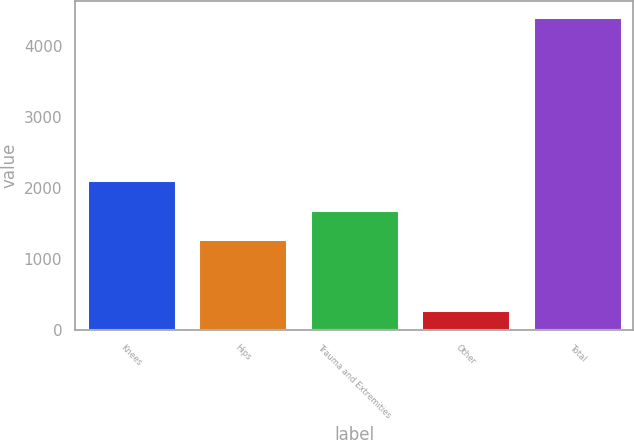<chart> <loc_0><loc_0><loc_500><loc_500><bar_chart><fcel>Knees<fcel>Hips<fcel>Trauma and Extremities<fcel>Other<fcel>Total<nl><fcel>2110.4<fcel>1283<fcel>1696.7<fcel>285<fcel>4422<nl></chart> 